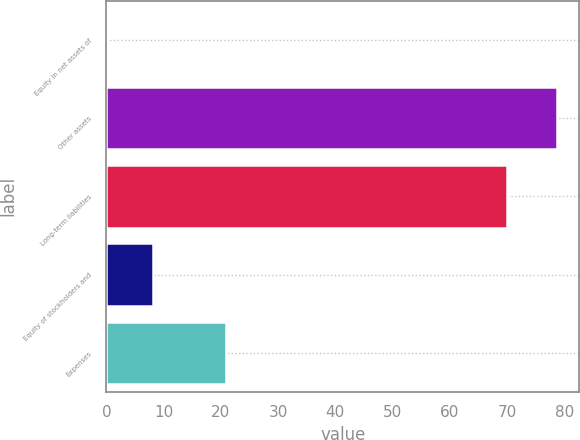Convert chart. <chart><loc_0><loc_0><loc_500><loc_500><bar_chart><fcel>Equity in net assets of<fcel>Other assets<fcel>Long-term liabilities<fcel>Equity of stockholders and<fcel>Expenses<nl><fcel>0.3<fcel>78.7<fcel>70<fcel>8.14<fcel>20.9<nl></chart> 